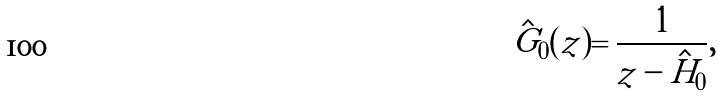<formula> <loc_0><loc_0><loc_500><loc_500>\hat { G } _ { 0 } ( z ) = \frac { 1 } { z - \hat { H } _ { 0 } } ,</formula> 